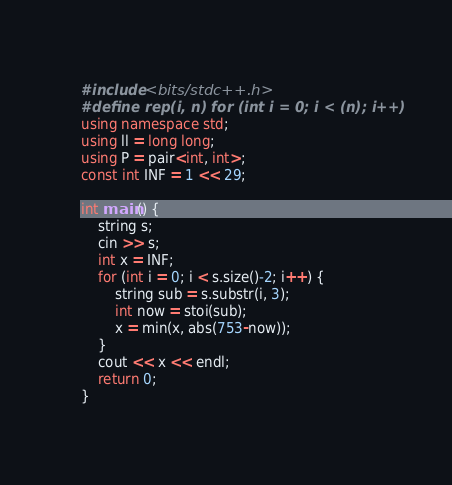<code> <loc_0><loc_0><loc_500><loc_500><_C++_>#include <bits/stdc++.h>
#define rep(i, n) for (int i = 0; i < (n); i++)
using namespace std;
using ll = long long;
using P = pair<int, int>;
const int INF = 1 << 29;

int main() {
	string s;
	cin >> s;
	int x = INF;
	for (int i = 0; i < s.size()-2; i++) {
		string sub = s.substr(i, 3);
		int now = stoi(sub);
		x = min(x, abs(753-now));
	}
	cout << x << endl;
	return 0;
}</code> 